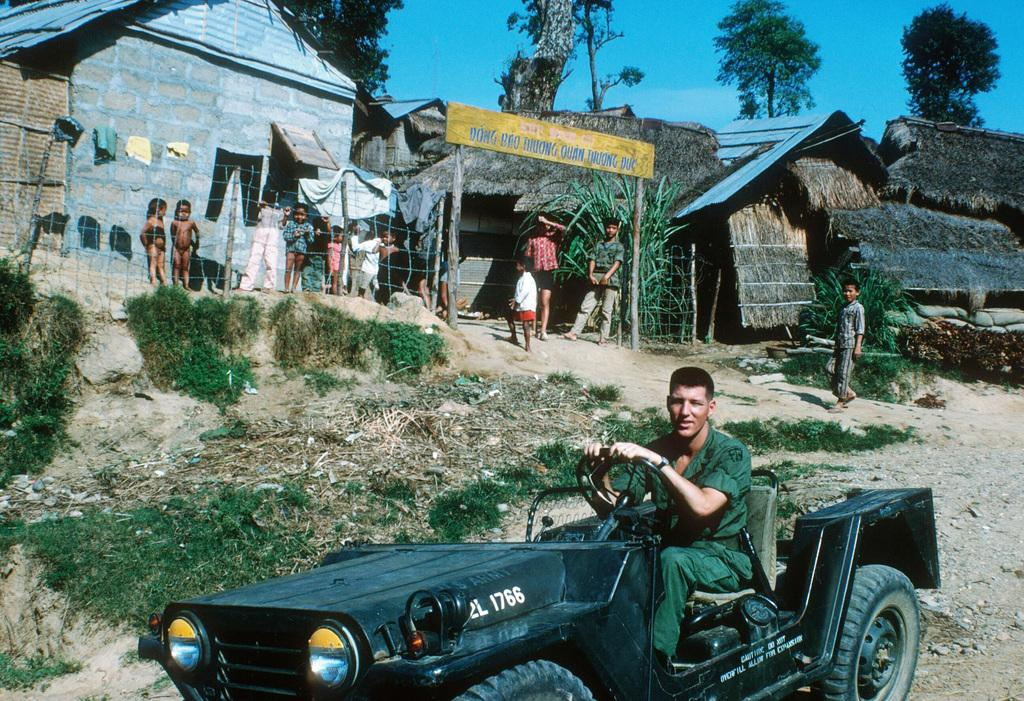What is the main subject of the image? The main subject of the image is a person driving a car. Are there any other people in the image? Yes, there are people standing at the back side of the car. What is the background of the image like? The background includes an arch, houses, and a tree. What type of religion is being practiced by the boy in the image? There is no boy present in the image, and no religious practice is depicted. What type of teeth can be seen in the image? There are no teeth visible in the image. 